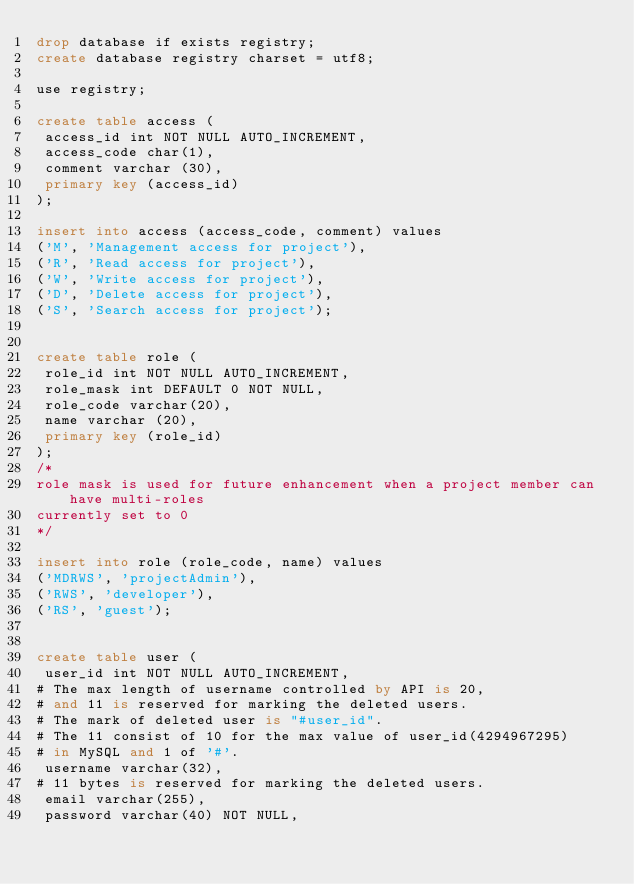Convert code to text. <code><loc_0><loc_0><loc_500><loc_500><_SQL_>drop database if exists registry;
create database registry charset = utf8;

use registry;

create table access (
 access_id int NOT NULL AUTO_INCREMENT,
 access_code char(1),
 comment varchar (30),
 primary key (access_id)
);

insert into access (access_code, comment) values 
('M', 'Management access for project'),
('R', 'Read access for project'),
('W', 'Write access for project'),
('D', 'Delete access for project'),
('S', 'Search access for project');


create table role (
 role_id int NOT NULL AUTO_INCREMENT,
 role_mask int DEFAULT 0 NOT NULL,
 role_code varchar(20),
 name varchar (20),
 primary key (role_id)
);
/*
role mask is used for future enhancement when a project member can have multi-roles
currently set to 0
*/

insert into role (role_code, name) values 
('MDRWS', 'projectAdmin'),
('RWS', 'developer'),
('RS', 'guest');


create table user (
 user_id int NOT NULL AUTO_INCREMENT,
# The max length of username controlled by API is 20, 
# and 11 is reserved for marking the deleted users.
# The mark of deleted user is "#user_id".
# The 11 consist of 10 for the max value of user_id(4294967295)  
# in MySQL and 1 of '#'.
 username varchar(32),
# 11 bytes is reserved for marking the deleted users.
 email varchar(255),
 password varchar(40) NOT NULL,</code> 